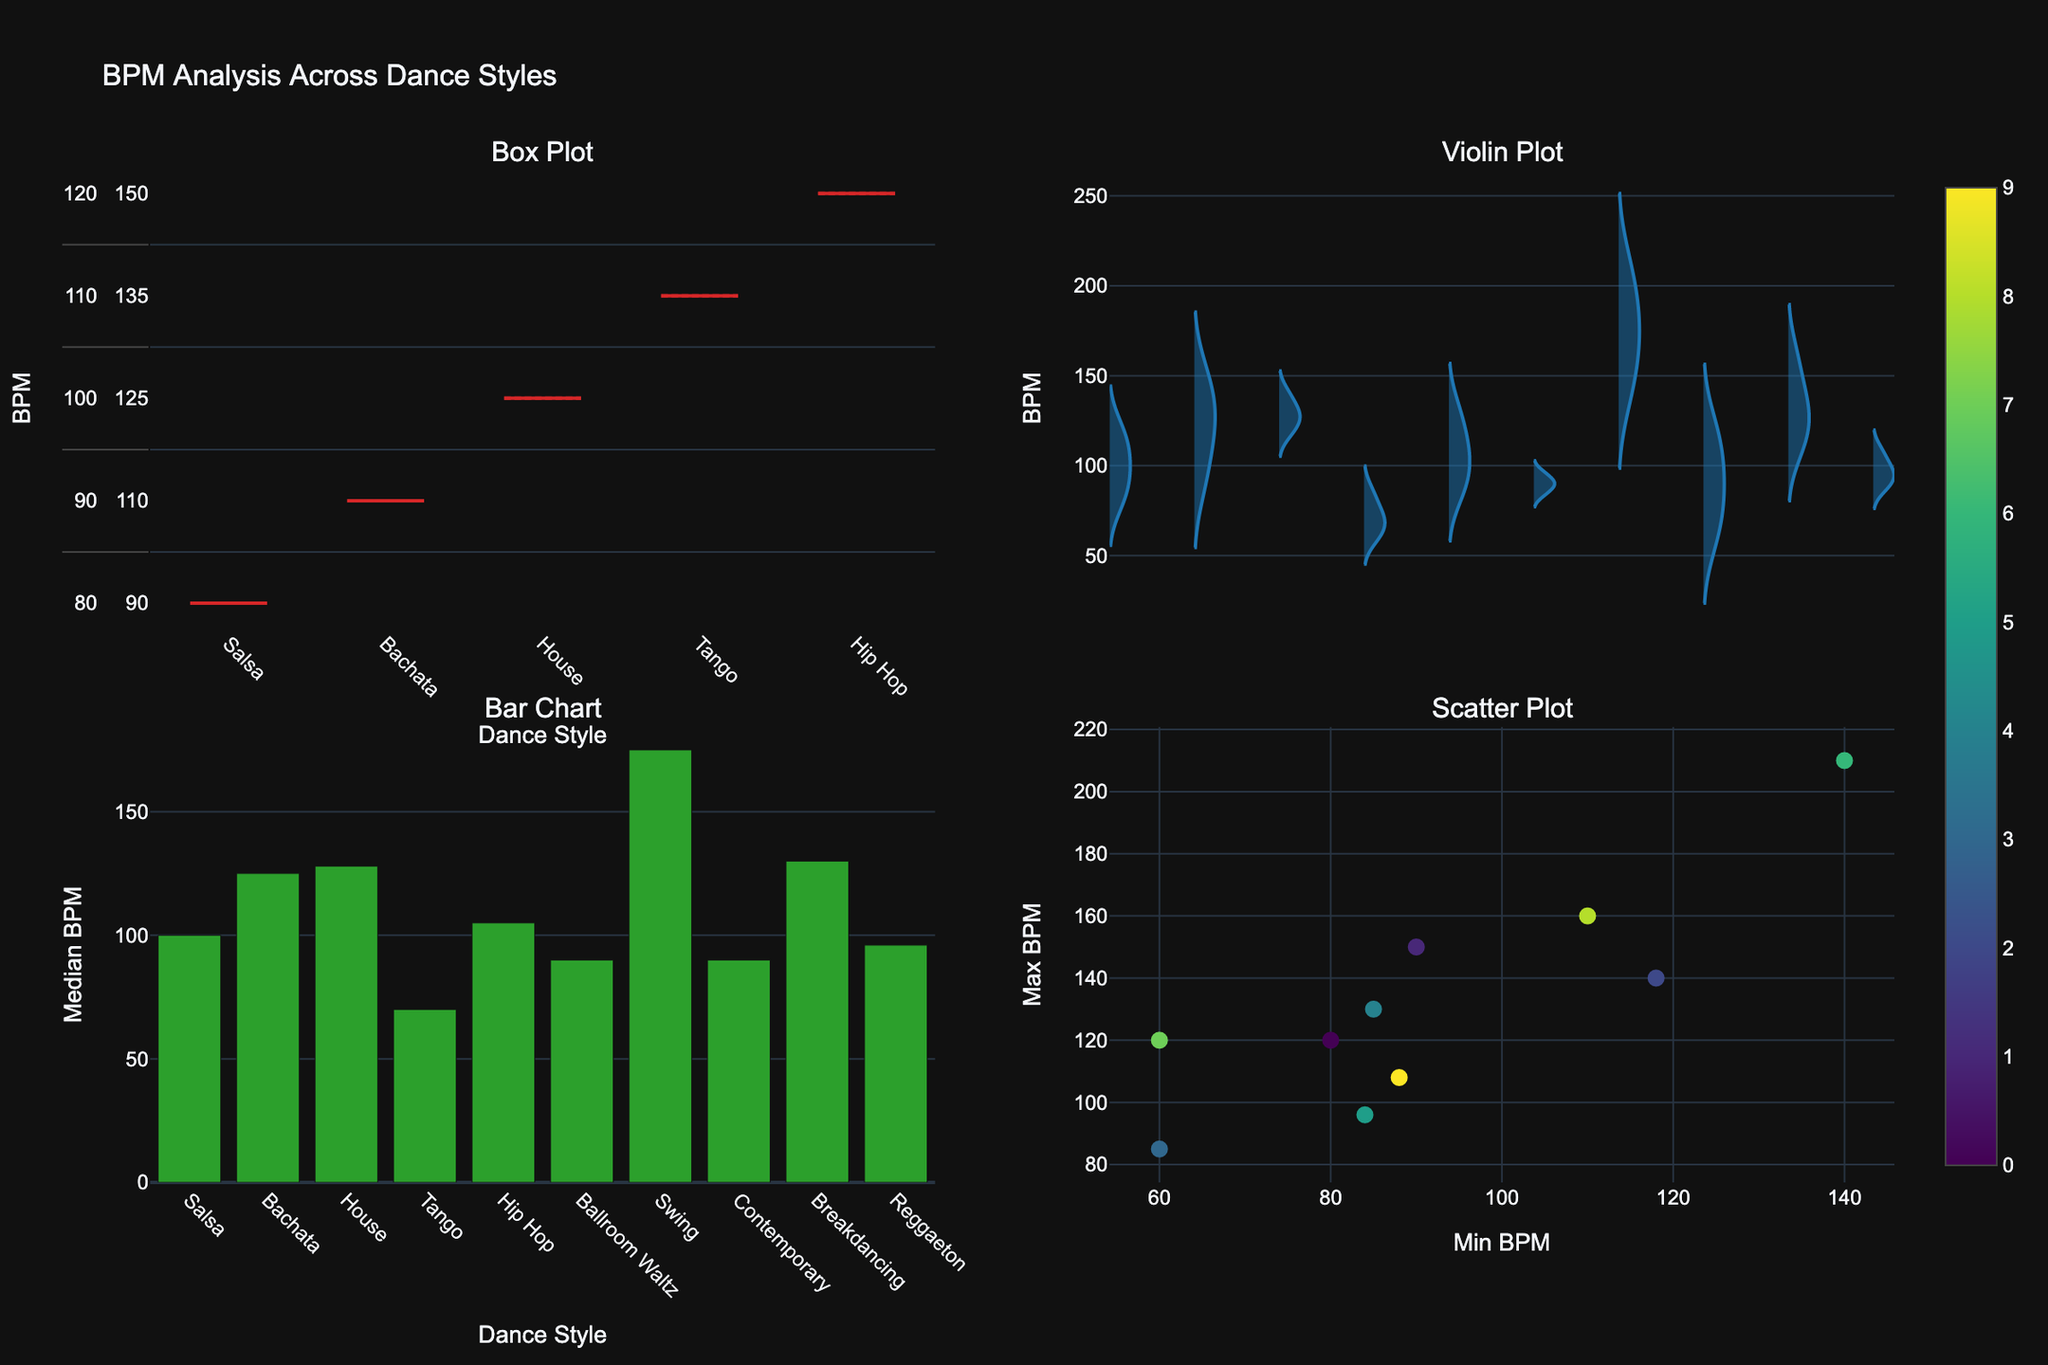How many dance styles are compared in the plots? Count the distinct dance styles mentioned in the x-axis of the Box Plot or Bar Chart.
Answer: 10 Which dance style has the highest maximum BPM in the Box Plot? Look at the maximum whisker in the Box Plot and find the highest point.
Answer: Swing What's the median BPM for Bachata as shown in the Bar Chart? Find the height of the bar corresponding to Bachata in the Bar Chart.
Answer: 125 What is the difference between the minimum BPM of Tango and Reggaeton in the Scatter Plot? Find the minimum BPM for Tango and Reggaeton and subtract them. Tango's minimum BPM is 60 and Reggaeton's is 88, then calculate 88 - 60.
Answer: 28 Which dance styles have their maximum BPM below 100 according to the Scatter Plot? Look for points in the Scatter Plot where Max BPM is below 100, and check their text labels.
Answer: Tango, Ballroom Waltz, Reggaeton What is the interquartile range (IQR) of BPM for House in the Violin Plot? Locate the quartiles Q1 and Q3 in the Violin Plot for House; the IQR is Q3 - Q1. House's Q1 is 124 and Q3 is 132, so calculate 132 - 124.
Answer: 8 Which dance style has the narrowest BPM range according to the Box Plot? Identify the dance style with the smallest difference between the minimum and maximum BPM in the Box Plot.
Answer: Ballroom Waltz Compare the median BPM for Hip Hop and Swing in the Bar Chart. Which one is higher? Find the heights of the bars for Hip Hop and Swing, then compare them. Hip Hop's median BPM is 105 and Swing's is 175.
Answer: Swing Which dance styles have a median BPM higher than 120 according to the Bar Chart? Identify the dance styles with median BPM bars higher than 120 in the Bar Chart.
Answer: Bachata, Swing, Breakdancing How does the BPM range of House compare to Breakdancing in the Box Plot? Examine the spread between min and max BPM for both House and Breakdancing in the Box Plot. House ranges from 118 to 140, while Breakdancing ranges from 110 to 160.
Answer: Breakdancing has a wider range 